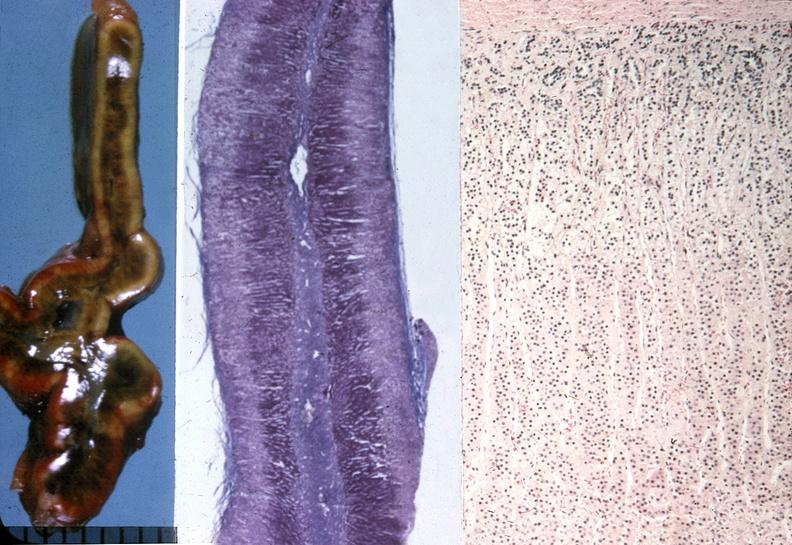what does this image show?
Answer the question using a single word or phrase. Adrenal 